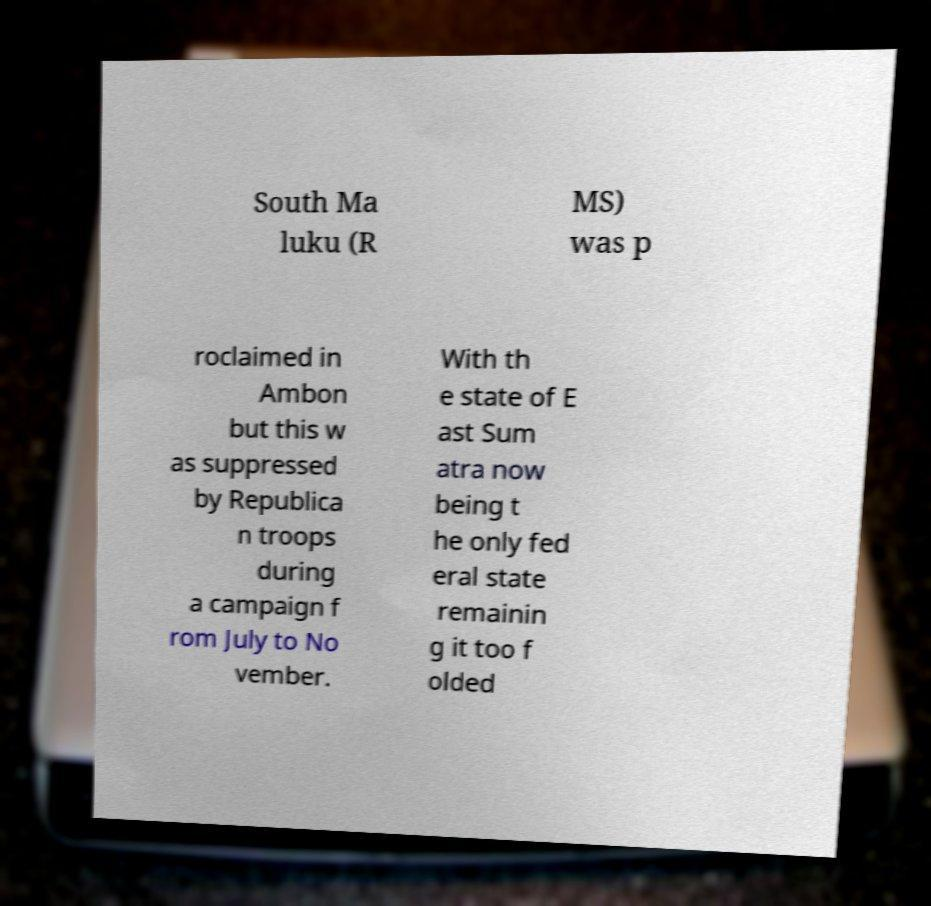There's text embedded in this image that I need extracted. Can you transcribe it verbatim? South Ma luku (R MS) was p roclaimed in Ambon but this w as suppressed by Republica n troops during a campaign f rom July to No vember. With th e state of E ast Sum atra now being t he only fed eral state remainin g it too f olded 